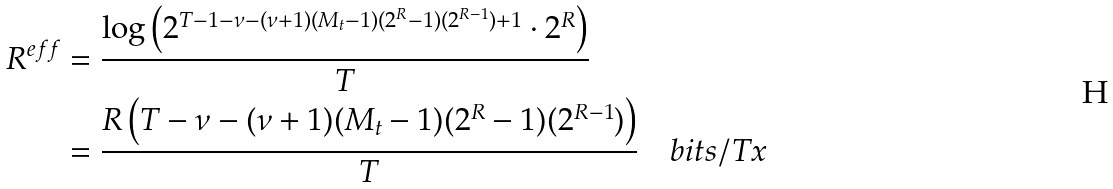<formula> <loc_0><loc_0><loc_500><loc_500>R ^ { e f f } & = \frac { \log \left ( 2 ^ { T - 1 - \nu - ( \nu + 1 ) ( M _ { t } - 1 ) ( 2 ^ { R } - 1 ) ( 2 ^ { R - 1 } ) + 1 } \cdot 2 ^ { R } \right ) } { T } \\ & = \frac { R \left ( T - \nu - ( \nu + 1 ) ( M _ { t } - 1 ) ( 2 ^ { R } - 1 ) ( 2 ^ { R - 1 } ) \right ) } { T } \quad b i t s / T x</formula> 